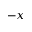<formula> <loc_0><loc_0><loc_500><loc_500>- x</formula> 